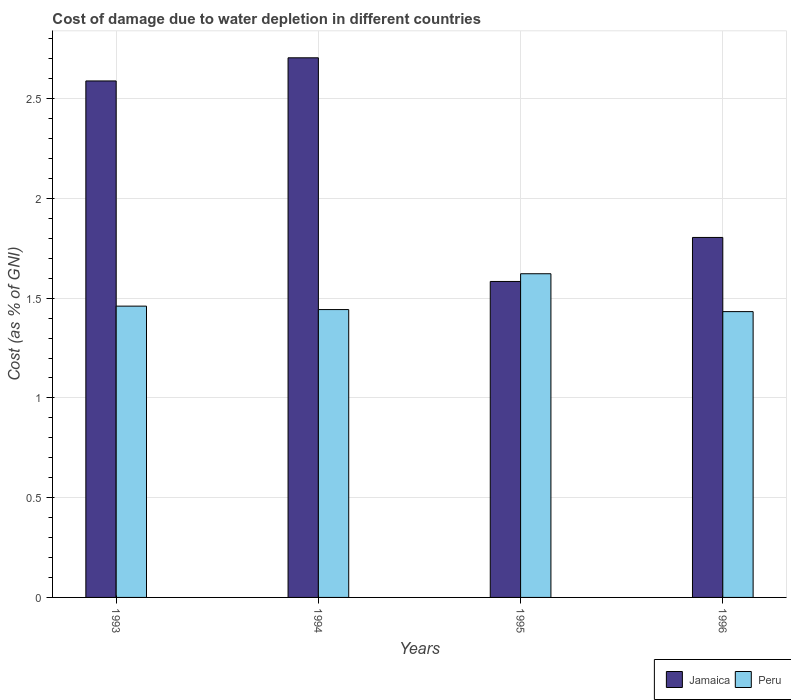How many bars are there on the 1st tick from the right?
Your response must be concise. 2. What is the label of the 2nd group of bars from the left?
Your response must be concise. 1994. What is the cost of damage caused due to water depletion in Jamaica in 1994?
Your answer should be compact. 2.7. Across all years, what is the maximum cost of damage caused due to water depletion in Peru?
Give a very brief answer. 1.62. Across all years, what is the minimum cost of damage caused due to water depletion in Peru?
Offer a very short reply. 1.43. In which year was the cost of damage caused due to water depletion in Jamaica maximum?
Ensure brevity in your answer.  1994. What is the total cost of damage caused due to water depletion in Jamaica in the graph?
Give a very brief answer. 8.68. What is the difference between the cost of damage caused due to water depletion in Jamaica in 1994 and that in 1996?
Your response must be concise. 0.9. What is the difference between the cost of damage caused due to water depletion in Jamaica in 1996 and the cost of damage caused due to water depletion in Peru in 1994?
Offer a very short reply. 0.36. What is the average cost of damage caused due to water depletion in Peru per year?
Keep it short and to the point. 1.49. In the year 1993, what is the difference between the cost of damage caused due to water depletion in Peru and cost of damage caused due to water depletion in Jamaica?
Provide a succinct answer. -1.13. What is the ratio of the cost of damage caused due to water depletion in Peru in 1993 to that in 1995?
Provide a succinct answer. 0.9. Is the difference between the cost of damage caused due to water depletion in Peru in 1993 and 1995 greater than the difference between the cost of damage caused due to water depletion in Jamaica in 1993 and 1995?
Give a very brief answer. No. What is the difference between the highest and the second highest cost of damage caused due to water depletion in Peru?
Give a very brief answer. 0.16. What is the difference between the highest and the lowest cost of damage caused due to water depletion in Peru?
Give a very brief answer. 0.19. In how many years, is the cost of damage caused due to water depletion in Peru greater than the average cost of damage caused due to water depletion in Peru taken over all years?
Ensure brevity in your answer.  1. What does the 2nd bar from the left in 1995 represents?
Offer a very short reply. Peru. What does the 2nd bar from the right in 1993 represents?
Ensure brevity in your answer.  Jamaica. Are all the bars in the graph horizontal?
Offer a very short reply. No. Does the graph contain grids?
Your response must be concise. Yes. What is the title of the graph?
Keep it short and to the point. Cost of damage due to water depletion in different countries. What is the label or title of the X-axis?
Provide a succinct answer. Years. What is the label or title of the Y-axis?
Offer a terse response. Cost (as % of GNI). What is the Cost (as % of GNI) in Jamaica in 1993?
Your answer should be compact. 2.59. What is the Cost (as % of GNI) in Peru in 1993?
Ensure brevity in your answer.  1.46. What is the Cost (as % of GNI) of Jamaica in 1994?
Your answer should be compact. 2.7. What is the Cost (as % of GNI) of Peru in 1994?
Offer a terse response. 1.44. What is the Cost (as % of GNI) in Jamaica in 1995?
Your response must be concise. 1.58. What is the Cost (as % of GNI) of Peru in 1995?
Make the answer very short. 1.62. What is the Cost (as % of GNI) of Jamaica in 1996?
Provide a succinct answer. 1.8. What is the Cost (as % of GNI) of Peru in 1996?
Make the answer very short. 1.43. Across all years, what is the maximum Cost (as % of GNI) of Jamaica?
Make the answer very short. 2.7. Across all years, what is the maximum Cost (as % of GNI) of Peru?
Give a very brief answer. 1.62. Across all years, what is the minimum Cost (as % of GNI) in Jamaica?
Make the answer very short. 1.58. Across all years, what is the minimum Cost (as % of GNI) of Peru?
Your answer should be very brief. 1.43. What is the total Cost (as % of GNI) of Jamaica in the graph?
Keep it short and to the point. 8.68. What is the total Cost (as % of GNI) of Peru in the graph?
Your answer should be compact. 5.96. What is the difference between the Cost (as % of GNI) in Jamaica in 1993 and that in 1994?
Ensure brevity in your answer.  -0.12. What is the difference between the Cost (as % of GNI) in Peru in 1993 and that in 1994?
Offer a very short reply. 0.02. What is the difference between the Cost (as % of GNI) in Peru in 1993 and that in 1995?
Offer a very short reply. -0.16. What is the difference between the Cost (as % of GNI) in Jamaica in 1993 and that in 1996?
Provide a succinct answer. 0.78. What is the difference between the Cost (as % of GNI) of Peru in 1993 and that in 1996?
Make the answer very short. 0.03. What is the difference between the Cost (as % of GNI) in Jamaica in 1994 and that in 1995?
Your response must be concise. 1.12. What is the difference between the Cost (as % of GNI) of Peru in 1994 and that in 1995?
Ensure brevity in your answer.  -0.18. What is the difference between the Cost (as % of GNI) in Jamaica in 1994 and that in 1996?
Provide a succinct answer. 0.9. What is the difference between the Cost (as % of GNI) of Peru in 1994 and that in 1996?
Your answer should be very brief. 0.01. What is the difference between the Cost (as % of GNI) in Jamaica in 1995 and that in 1996?
Your response must be concise. -0.22. What is the difference between the Cost (as % of GNI) in Peru in 1995 and that in 1996?
Your response must be concise. 0.19. What is the difference between the Cost (as % of GNI) in Jamaica in 1993 and the Cost (as % of GNI) in Peru in 1994?
Provide a short and direct response. 1.15. What is the difference between the Cost (as % of GNI) of Jamaica in 1993 and the Cost (as % of GNI) of Peru in 1995?
Keep it short and to the point. 0.97. What is the difference between the Cost (as % of GNI) of Jamaica in 1993 and the Cost (as % of GNI) of Peru in 1996?
Give a very brief answer. 1.16. What is the difference between the Cost (as % of GNI) of Jamaica in 1994 and the Cost (as % of GNI) of Peru in 1995?
Your answer should be compact. 1.08. What is the difference between the Cost (as % of GNI) in Jamaica in 1994 and the Cost (as % of GNI) in Peru in 1996?
Keep it short and to the point. 1.27. What is the difference between the Cost (as % of GNI) of Jamaica in 1995 and the Cost (as % of GNI) of Peru in 1996?
Your answer should be compact. 0.15. What is the average Cost (as % of GNI) in Jamaica per year?
Your answer should be very brief. 2.17. What is the average Cost (as % of GNI) of Peru per year?
Provide a succinct answer. 1.49. In the year 1993, what is the difference between the Cost (as % of GNI) in Jamaica and Cost (as % of GNI) in Peru?
Offer a very short reply. 1.13. In the year 1994, what is the difference between the Cost (as % of GNI) in Jamaica and Cost (as % of GNI) in Peru?
Make the answer very short. 1.26. In the year 1995, what is the difference between the Cost (as % of GNI) in Jamaica and Cost (as % of GNI) in Peru?
Your answer should be compact. -0.04. In the year 1996, what is the difference between the Cost (as % of GNI) of Jamaica and Cost (as % of GNI) of Peru?
Ensure brevity in your answer.  0.37. What is the ratio of the Cost (as % of GNI) in Jamaica in 1993 to that in 1994?
Keep it short and to the point. 0.96. What is the ratio of the Cost (as % of GNI) in Peru in 1993 to that in 1994?
Offer a terse response. 1.01. What is the ratio of the Cost (as % of GNI) of Jamaica in 1993 to that in 1995?
Keep it short and to the point. 1.63. What is the ratio of the Cost (as % of GNI) of Peru in 1993 to that in 1995?
Your response must be concise. 0.9. What is the ratio of the Cost (as % of GNI) in Jamaica in 1993 to that in 1996?
Ensure brevity in your answer.  1.43. What is the ratio of the Cost (as % of GNI) in Peru in 1993 to that in 1996?
Give a very brief answer. 1.02. What is the ratio of the Cost (as % of GNI) in Jamaica in 1994 to that in 1995?
Your response must be concise. 1.71. What is the ratio of the Cost (as % of GNI) of Peru in 1994 to that in 1995?
Provide a short and direct response. 0.89. What is the ratio of the Cost (as % of GNI) of Jamaica in 1994 to that in 1996?
Your response must be concise. 1.5. What is the ratio of the Cost (as % of GNI) of Peru in 1994 to that in 1996?
Offer a terse response. 1.01. What is the ratio of the Cost (as % of GNI) in Jamaica in 1995 to that in 1996?
Make the answer very short. 0.88. What is the ratio of the Cost (as % of GNI) of Peru in 1995 to that in 1996?
Provide a short and direct response. 1.13. What is the difference between the highest and the second highest Cost (as % of GNI) in Jamaica?
Your answer should be very brief. 0.12. What is the difference between the highest and the second highest Cost (as % of GNI) of Peru?
Offer a very short reply. 0.16. What is the difference between the highest and the lowest Cost (as % of GNI) of Jamaica?
Offer a terse response. 1.12. What is the difference between the highest and the lowest Cost (as % of GNI) in Peru?
Offer a very short reply. 0.19. 